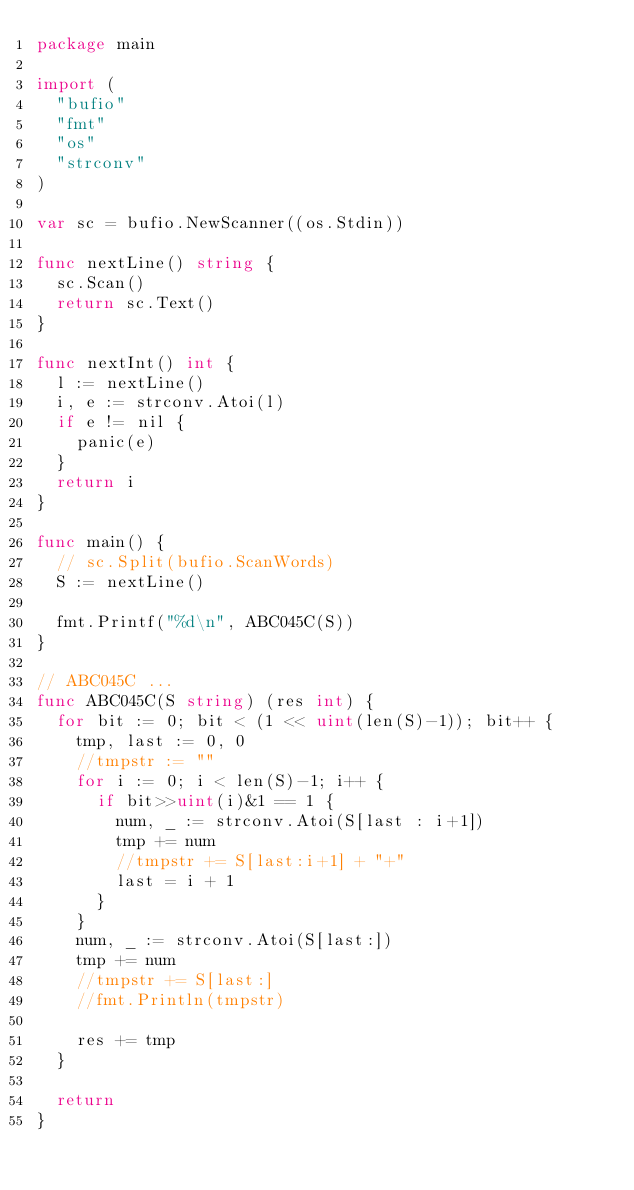<code> <loc_0><loc_0><loc_500><loc_500><_Go_>package main

import (
	"bufio"
	"fmt"
	"os"
	"strconv"
)

var sc = bufio.NewScanner((os.Stdin))

func nextLine() string {
	sc.Scan()
	return sc.Text()
}

func nextInt() int {
	l := nextLine()
	i, e := strconv.Atoi(l)
	if e != nil {
		panic(e)
	}
	return i
}

func main() {
	// sc.Split(bufio.ScanWords)
	S := nextLine()

	fmt.Printf("%d\n", ABC045C(S))
}

// ABC045C ...
func ABC045C(S string) (res int) {
	for bit := 0; bit < (1 << uint(len(S)-1)); bit++ {
		tmp, last := 0, 0
		//tmpstr := ""
		for i := 0; i < len(S)-1; i++ {
			if bit>>uint(i)&1 == 1 {
				num, _ := strconv.Atoi(S[last : i+1])
				tmp += num
				//tmpstr += S[last:i+1] + "+"
				last = i + 1
			}
		}
		num, _ := strconv.Atoi(S[last:])
		tmp += num
		//tmpstr += S[last:]
		//fmt.Println(tmpstr)

		res += tmp
	}

	return
}
</code> 